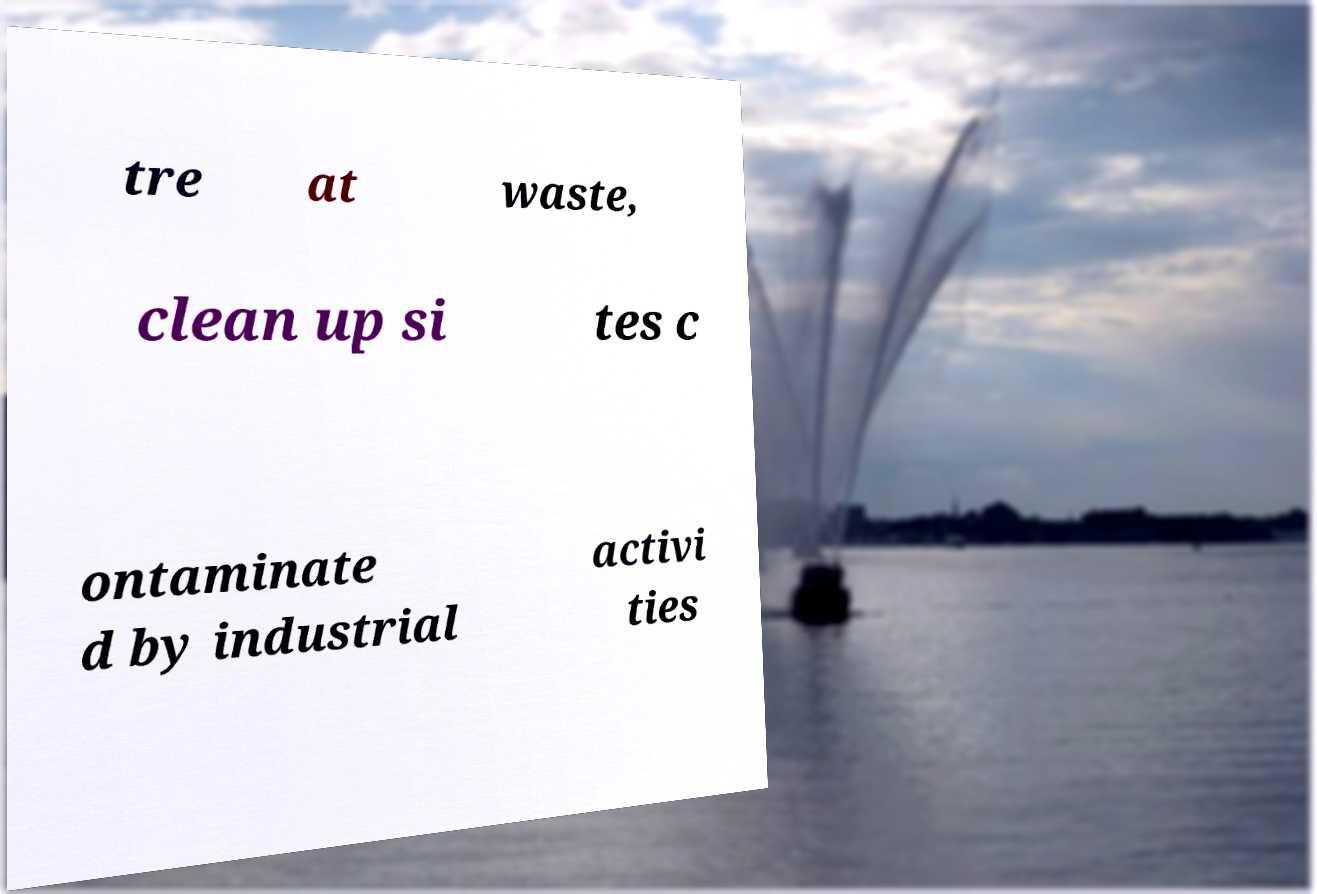What messages or text are displayed in this image? I need them in a readable, typed format. tre at waste, clean up si tes c ontaminate d by industrial activi ties 